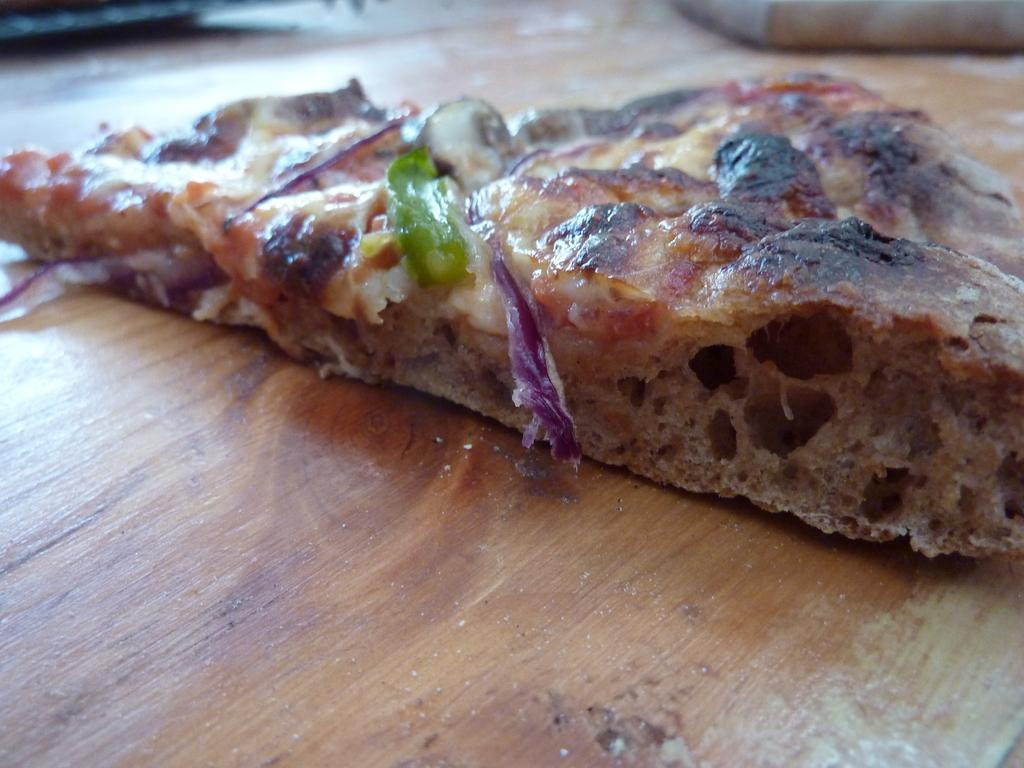What type of food is visible in the image? There is a piece of pizza in the image. Where is the piece of pizza located? The piece of pizza is present on a table. What type of fish can be seen swimming in the wilderness in the image? There is no fish or wilderness present in the image; it features a piece of pizza on a table. 